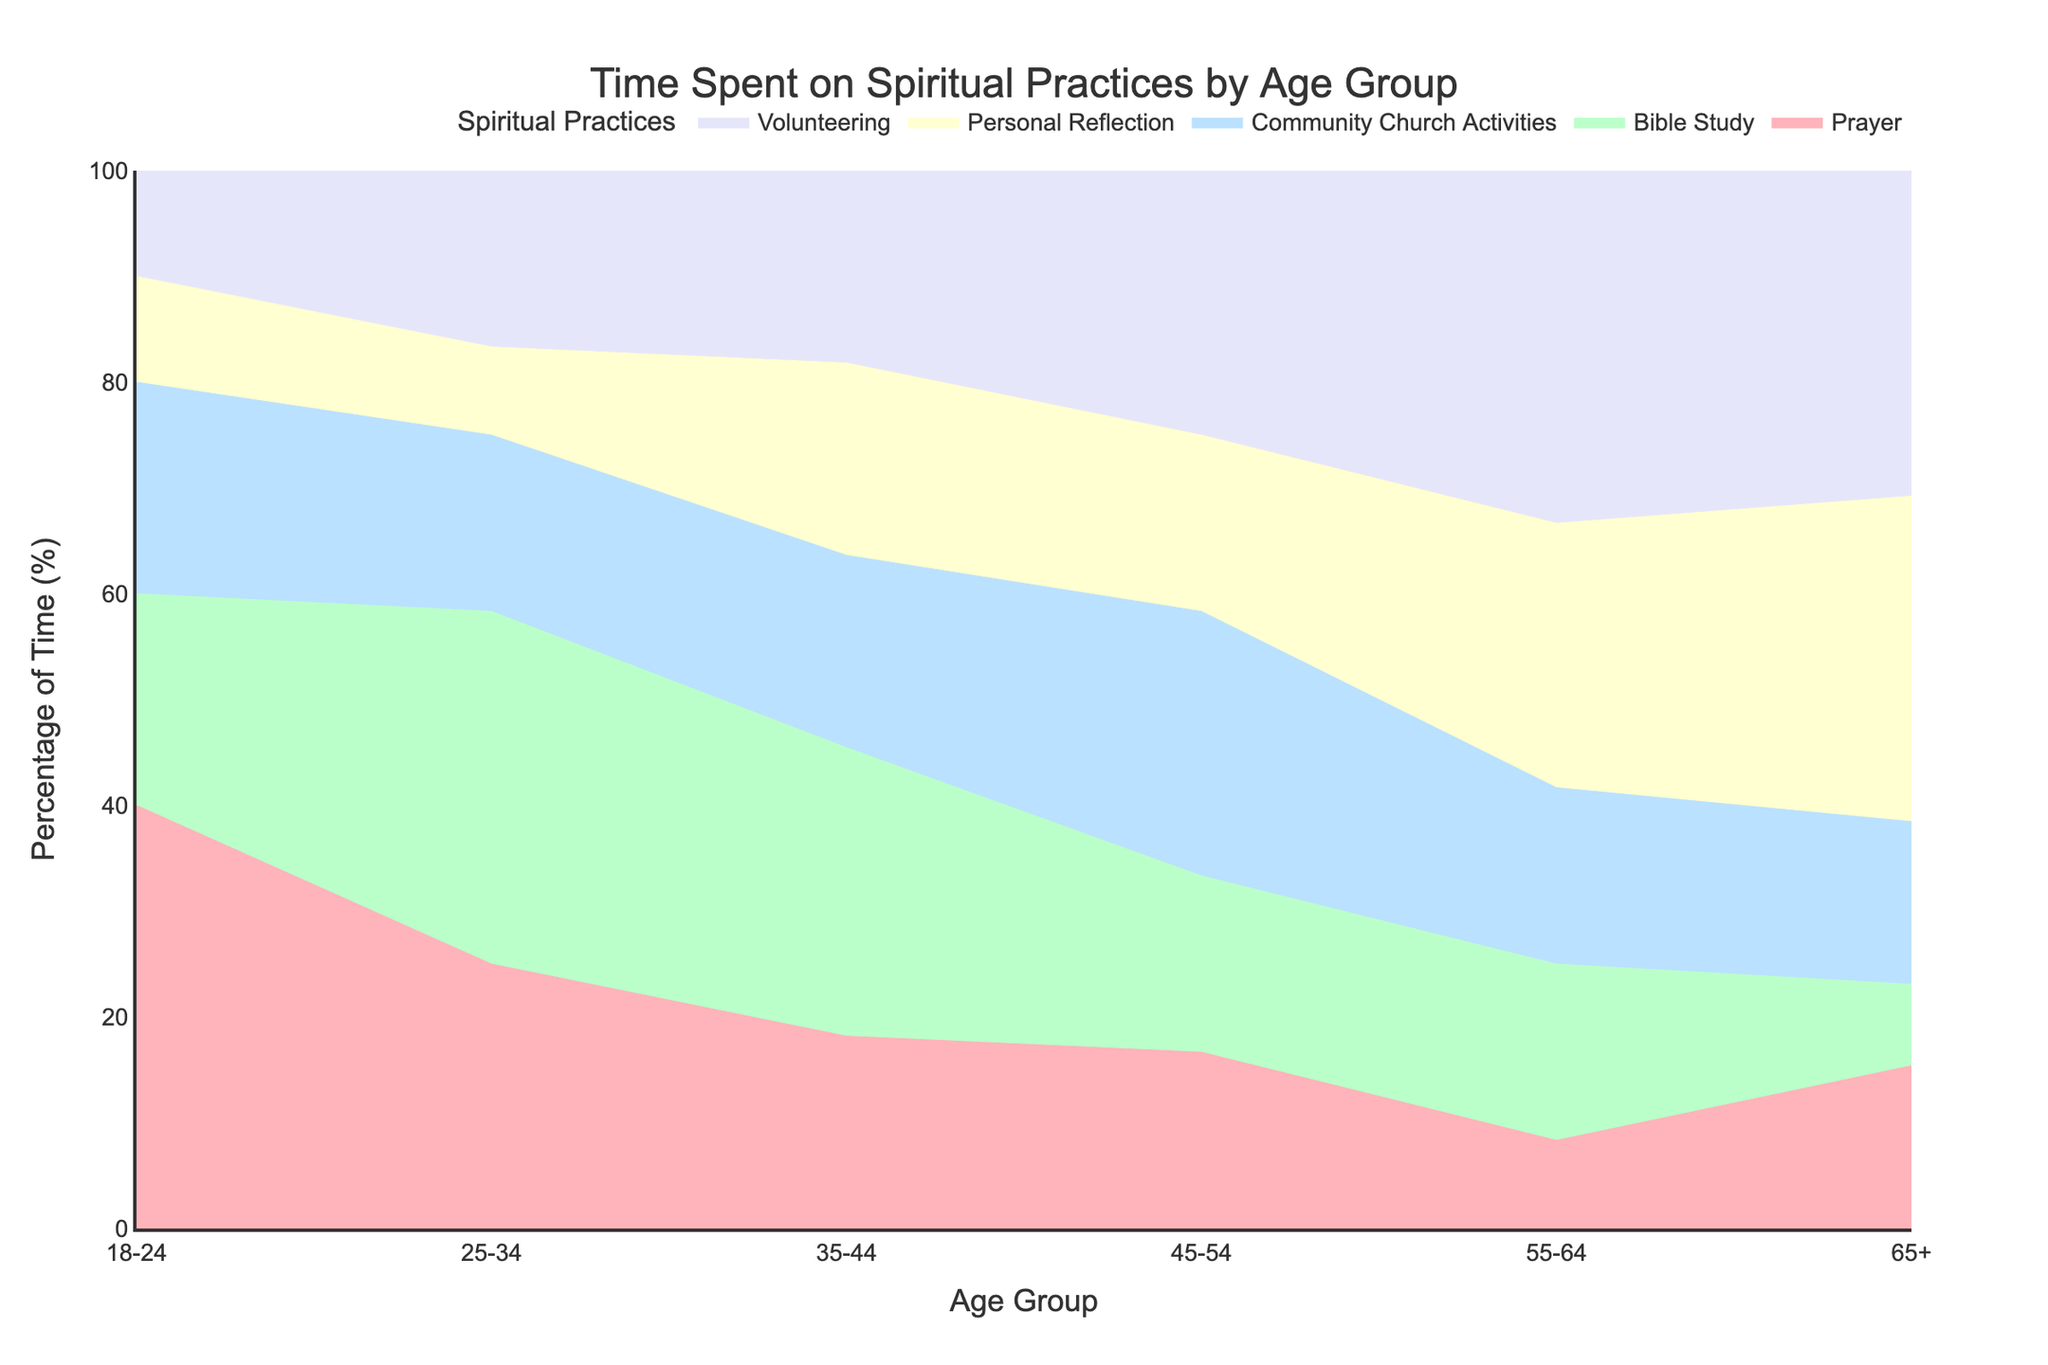What age group spends the largest percentage of their time on Bible Study? To determine the age group that spends the largest percentage of their time on Bible Study, observe the segment that represents Bible Study for each age group and identify which is the largest.
Answer: 25-34 Which spiritual practice has the highest percentage in the 55-64 age group? Look at the proportions of different practices within the 55-64 age group and identify the practice with the largest segment.
Answer: Volunteering Compare the time spent on Prayer between the 18-24 and 25-34 age groups. Identify the proportion of time spent on Prayer for both the 18-24 and 25-34 age groups and then compare these proportions.
Answer: The 18-24 age group spends a higher percentage of time on Prayer than the 25-34 age group What age group dedicates the least percentage of their time to Personal Reflection? Examine the proportion of time dedicated to Personal Reflection across all age groups and identify which group has the smallest segment for Personal Reflection.
Answer: 18-24 How does the percentage of time spent on Community Church Activities change from the 35-44 age group to the 45-54 age group? Compare the proportion of time spent on Community Church Activities between the 35-44 and 45-54 age groups to observe any changes.
Answer: It increases What spiritual practice takes up the largest percentage of time in the 65+ age group? Find the segment representing each practice in the 65+ age group and determine which one is the largest.
Answer: Personal Reflection Which practice shows the most noticeable increase in time percentage as age increases from 18-24 to 65+? Track the changes in the proportion of time spent on each spiritual practice from the 18-24 age group to the 65+ age group and identify the one with the most significant increase.
Answer: Personal Reflection Which age group spends a larger percentage of their time on Volunteering: 45-54 or 55-64? Compare the proportion of time spent on Volunteering between the 45-54 and 55-64 age groups.
Answer: 55-64 